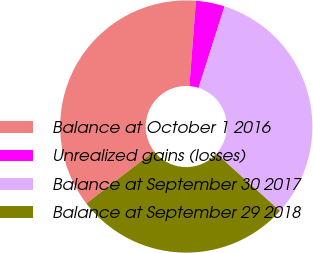Convert chart to OTSL. <chart><loc_0><loc_0><loc_500><loc_500><pie_chart><fcel>Balance at October 1 2016<fcel>Unrealized gains (losses)<fcel>Balance at September 30 2017<fcel>Balance at September 29 2018<nl><fcel>36.66%<fcel>3.69%<fcel>31.76%<fcel>27.89%<nl></chart> 